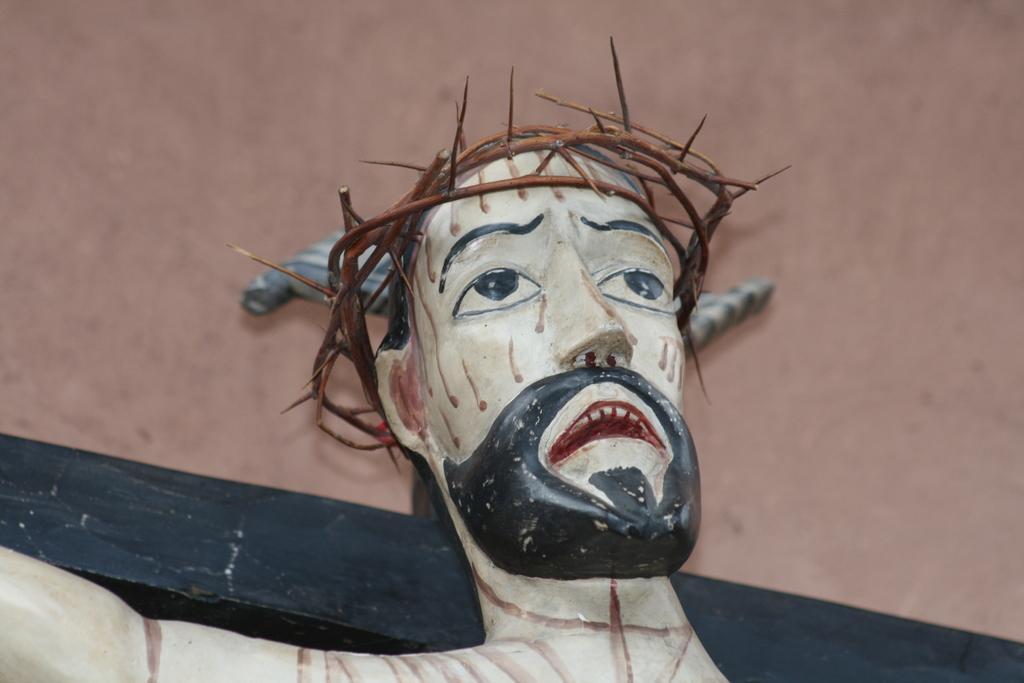Please provide a concise description of this image. The picture consists of a sculpture. At the top it is well. 